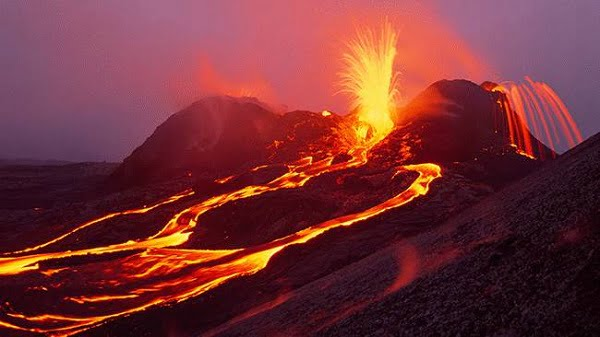Can you elaborate on the elements of the picture provided? The image vividly captures the eruption at Hawaii Volcanoes National Park, showcasing molten lava forcefully spewing from the Earth's crust. Bright orange streams of lava pour down the rugged terrain, glowing intensely against the bleak, twilight sky. The scene is set in an isolated, barren landscape, where the raw power of geothermal activity is unleashed, highlighting nature's capacity for both creation and destruction. This striking geological event illustrates the dynamic processes of earth's plate tectonics and magma movement, offering a spectacular, albeit dangerous spectacle of natural wonder. 